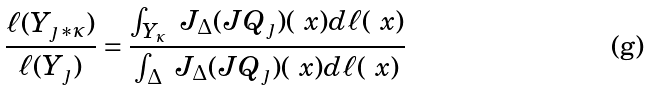<formula> <loc_0><loc_0><loc_500><loc_500>\frac { \ell ( Y _ { \jmath \ast \kappa } ) } { \ell ( Y _ { \jmath } ) } = \frac { \int _ { Y _ { \kappa } } \ J _ { \Delta } ( J Q _ { \jmath } ) ( \ x ) d \ell ( \ x ) } { \int _ { \Delta } \ J _ { \Delta } ( J Q _ { \jmath } ) ( \ x ) d \ell ( \ x ) }</formula> 